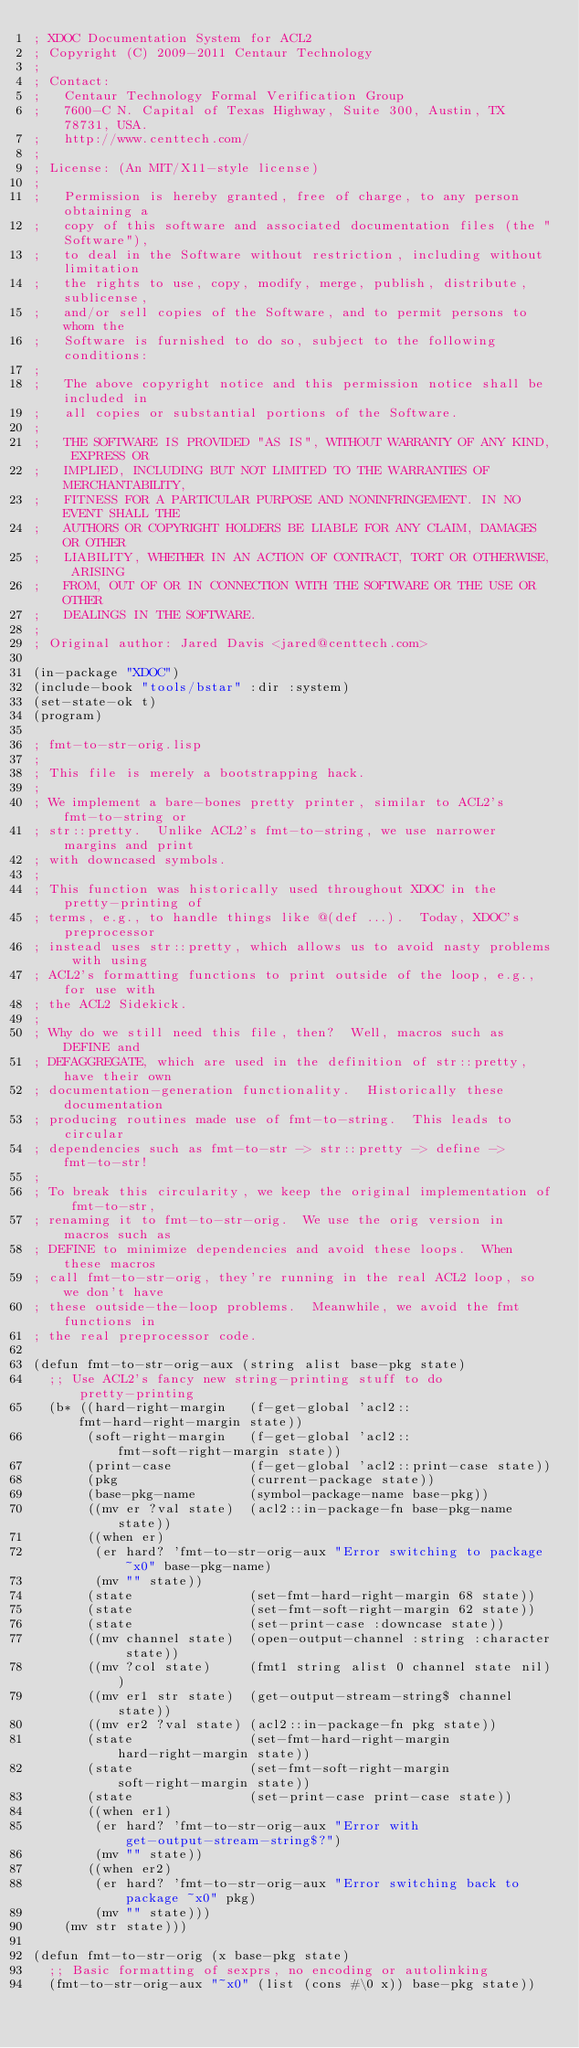Convert code to text. <code><loc_0><loc_0><loc_500><loc_500><_Lisp_>; XDOC Documentation System for ACL2
; Copyright (C) 2009-2011 Centaur Technology
;
; Contact:
;   Centaur Technology Formal Verification Group
;   7600-C N. Capital of Texas Highway, Suite 300, Austin, TX 78731, USA.
;   http://www.centtech.com/
;
; License: (An MIT/X11-style license)
;
;   Permission is hereby granted, free of charge, to any person obtaining a
;   copy of this software and associated documentation files (the "Software"),
;   to deal in the Software without restriction, including without limitation
;   the rights to use, copy, modify, merge, publish, distribute, sublicense,
;   and/or sell copies of the Software, and to permit persons to whom the
;   Software is furnished to do so, subject to the following conditions:
;
;   The above copyright notice and this permission notice shall be included in
;   all copies or substantial portions of the Software.
;
;   THE SOFTWARE IS PROVIDED "AS IS", WITHOUT WARRANTY OF ANY KIND, EXPRESS OR
;   IMPLIED, INCLUDING BUT NOT LIMITED TO THE WARRANTIES OF MERCHANTABILITY,
;   FITNESS FOR A PARTICULAR PURPOSE AND NONINFRINGEMENT. IN NO EVENT SHALL THE
;   AUTHORS OR COPYRIGHT HOLDERS BE LIABLE FOR ANY CLAIM, DAMAGES OR OTHER
;   LIABILITY, WHETHER IN AN ACTION OF CONTRACT, TORT OR OTHERWISE, ARISING
;   FROM, OUT OF OR IN CONNECTION WITH THE SOFTWARE OR THE USE OR OTHER
;   DEALINGS IN THE SOFTWARE.
;
; Original author: Jared Davis <jared@centtech.com>

(in-package "XDOC")
(include-book "tools/bstar" :dir :system)
(set-state-ok t)
(program)

; fmt-to-str-orig.lisp
;
; This file is merely a bootstrapping hack.
;
; We implement a bare-bones pretty printer, similar to ACL2's fmt-to-string or
; str::pretty.  Unlike ACL2's fmt-to-string, we use narrower margins and print
; with downcased symbols.
;
; This function was historically used throughout XDOC in the pretty-printing of
; terms, e.g., to handle things like @(def ...).  Today, XDOC's preprocessor
; instead uses str::pretty, which allows us to avoid nasty problems with using
; ACL2's formatting functions to print outside of the loop, e.g., for use with
; the ACL2 Sidekick.
;
; Why do we still need this file, then?  Well, macros such as DEFINE and
; DEFAGGREGATE, which are used in the definition of str::pretty, have their own
; documentation-generation functionality.  Historically these documentation
; producing routines made use of fmt-to-string.  This leads to circular
; dependencies such as fmt-to-str -> str::pretty -> define -> fmt-to-str!
;
; To break this circularity, we keep the original implementation of fmt-to-str,
; renaming it to fmt-to-str-orig.  We use the orig version in macros such as
; DEFINE to minimize dependencies and avoid these loops.  When these macros
; call fmt-to-str-orig, they're running in the real ACL2 loop, so we don't have
; these outside-the-loop problems.  Meanwhile, we avoid the fmt functions in
; the real preprocessor code.

(defun fmt-to-str-orig-aux (string alist base-pkg state)
  ;; Use ACL2's fancy new string-printing stuff to do pretty-printing
  (b* ((hard-right-margin   (f-get-global 'acl2::fmt-hard-right-margin state))
       (soft-right-margin   (f-get-global 'acl2::fmt-soft-right-margin state))
       (print-case          (f-get-global 'acl2::print-case state))
       (pkg                 (current-package state))
       (base-pkg-name       (symbol-package-name base-pkg))
       ((mv er ?val state)  (acl2::in-package-fn base-pkg-name state))
       ((when er)
        (er hard? 'fmt-to-str-orig-aux "Error switching to package ~x0" base-pkg-name)
        (mv "" state))
       (state               (set-fmt-hard-right-margin 68 state))
       (state               (set-fmt-soft-right-margin 62 state))
       (state               (set-print-case :downcase state))
       ((mv channel state)  (open-output-channel :string :character state))
       ((mv ?col state)     (fmt1 string alist 0 channel state nil))
       ((mv er1 str state)  (get-output-stream-string$ channel state))
       ((mv er2 ?val state) (acl2::in-package-fn pkg state))
       (state               (set-fmt-hard-right-margin hard-right-margin state))
       (state               (set-fmt-soft-right-margin soft-right-margin state))
       (state               (set-print-case print-case state))
       ((when er1)
        (er hard? 'fmt-to-str-orig-aux "Error with get-output-stream-string$?")
        (mv "" state))
       ((when er2)
        (er hard? 'fmt-to-str-orig-aux "Error switching back to package ~x0" pkg)
        (mv "" state)))
    (mv str state)))

(defun fmt-to-str-orig (x base-pkg state)
  ;; Basic formatting of sexprs, no encoding or autolinking
  (fmt-to-str-orig-aux "~x0" (list (cons #\0 x)) base-pkg state))
</code> 